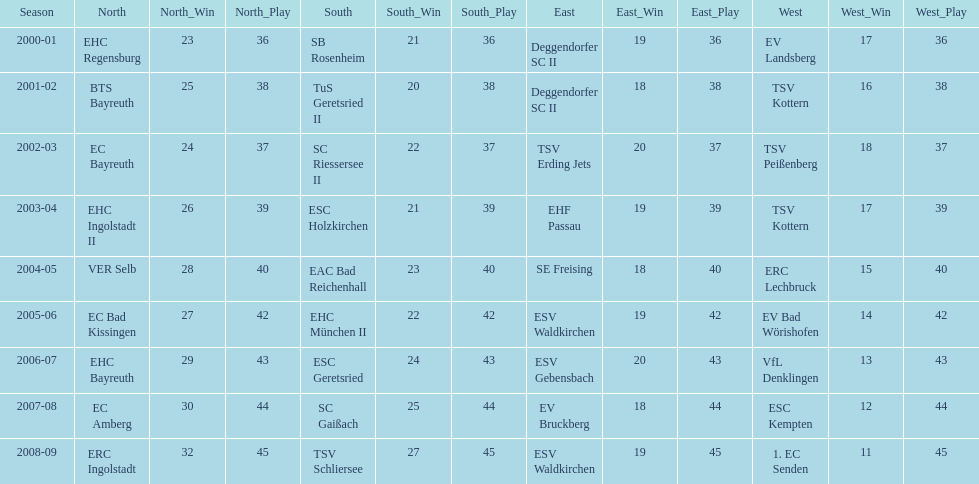The last team to win the west? 1. EC Senden. 